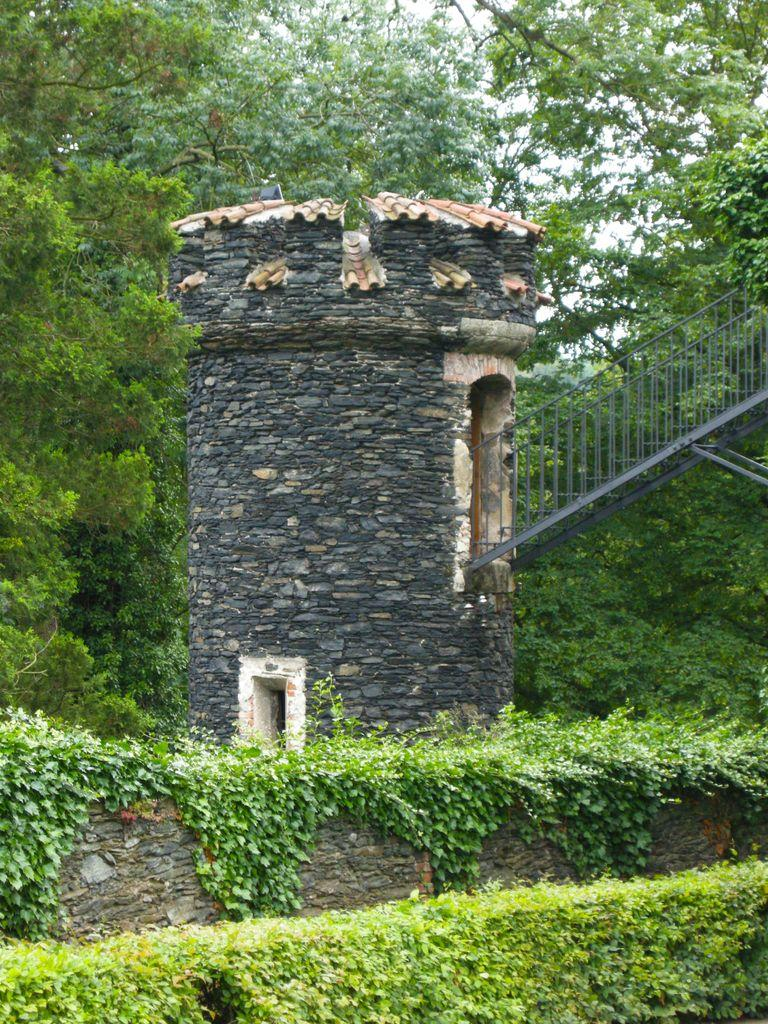What type of structure is visible in the image? There is a building in the image. What colors are used for the building? The building is in black and cream color. What architectural feature can be seen in the image? There is a railing and stairs visible in the image. What can be seen in the background of the image? There are trees and the sky visible in the background of the image. Can you see a snake slithering up the building in the image? There is no snake present in the image. What type of cactus can be seen growing on the building in the image? There is no cactus present on the building in the image. 